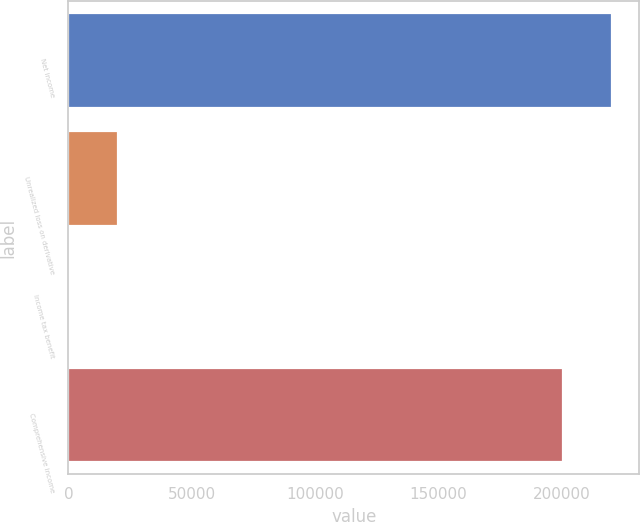Convert chart. <chart><loc_0><loc_0><loc_500><loc_500><bar_chart><fcel>Net income<fcel>Unrealized loss on derivative<fcel>Income tax benefit<fcel>Comprehensive income<nl><fcel>220450<fcel>20141.2<fcel>91<fcel>200400<nl></chart> 